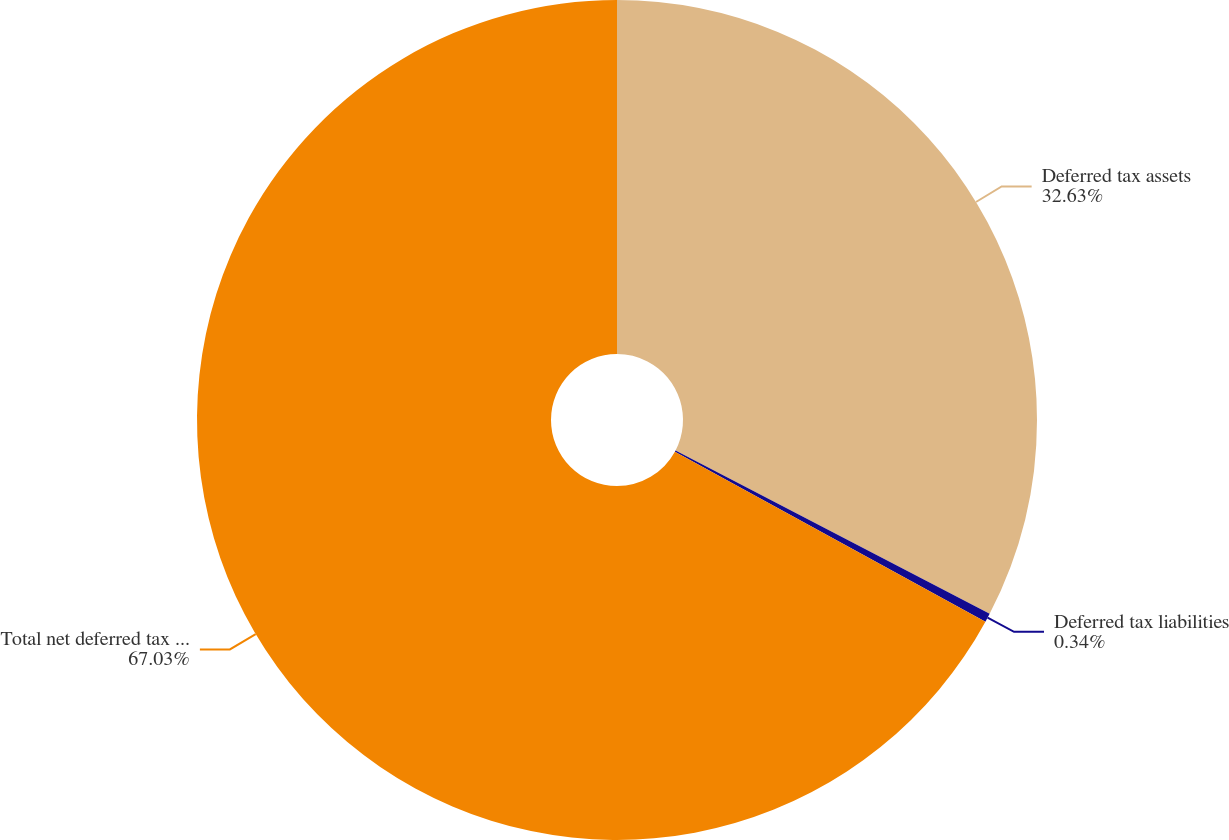Convert chart. <chart><loc_0><loc_0><loc_500><loc_500><pie_chart><fcel>Deferred tax assets<fcel>Deferred tax liabilities<fcel>Total net deferred tax assets<nl><fcel>32.63%<fcel>0.34%<fcel>67.03%<nl></chart> 